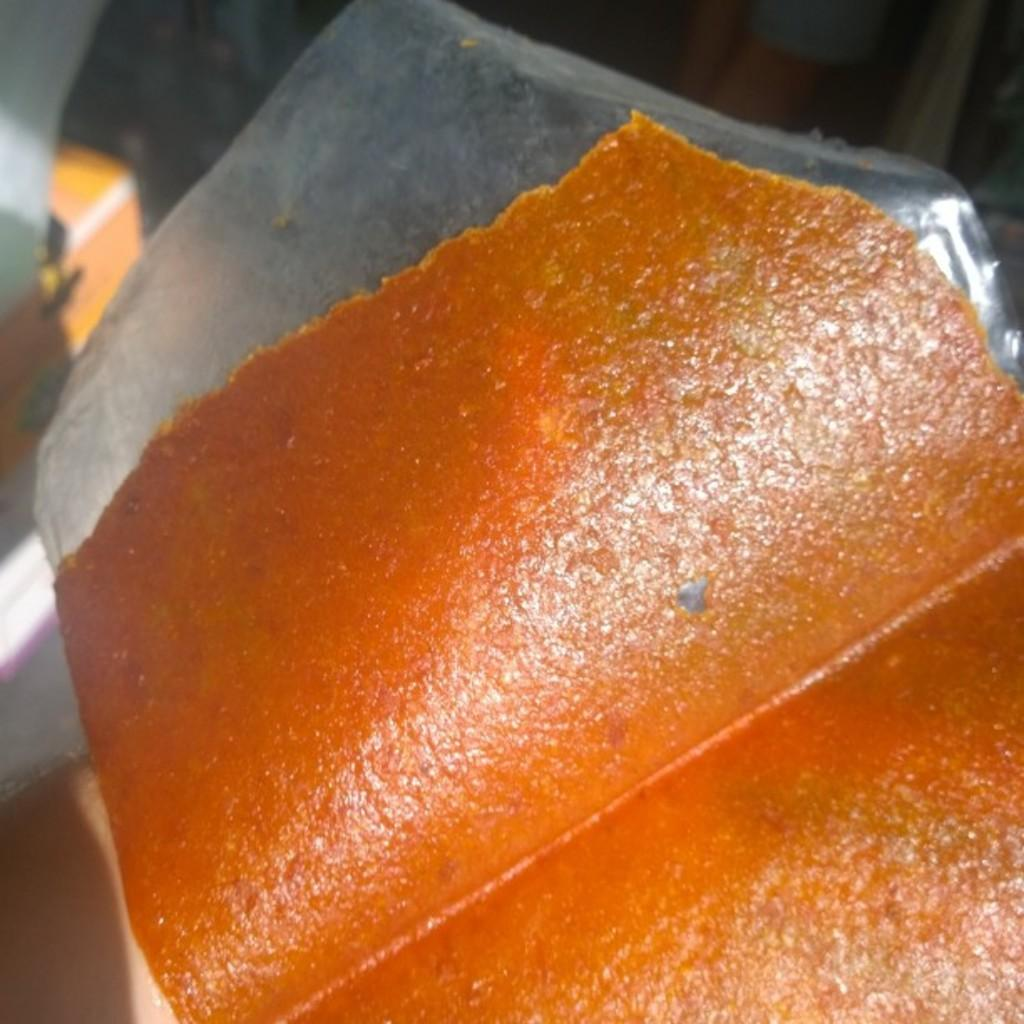What are the colors of the object in the image? The object is orange and silver in color. Is there a mailbox attached to the chain in the image? There is no mailbox or chain present in the image. 